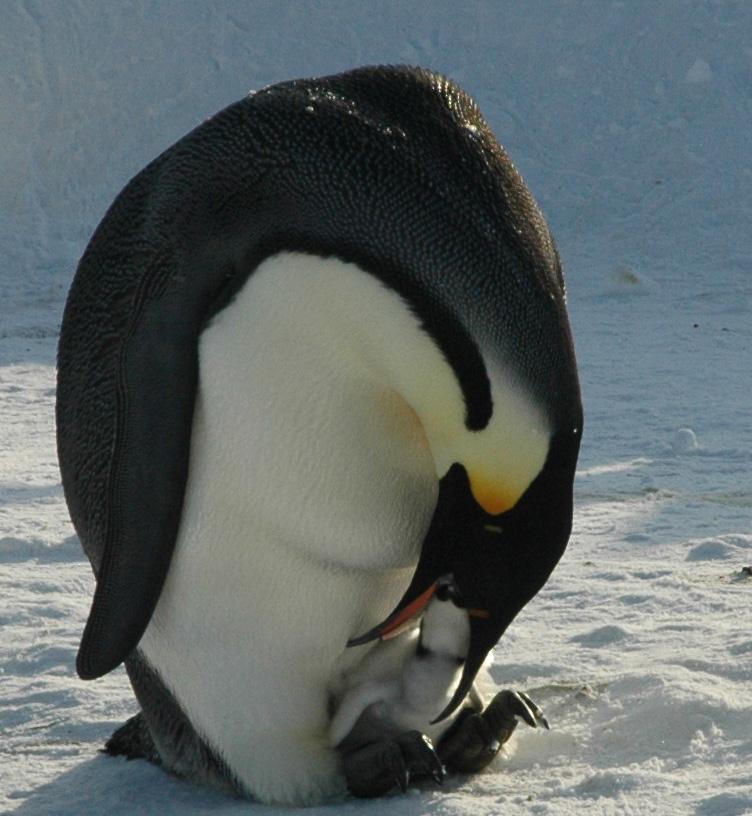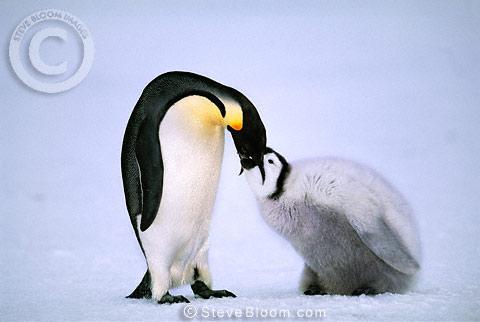The first image is the image on the left, the second image is the image on the right. Assess this claim about the two images: "One penguin is pushing a closed beak against the back of another penguin's head.". Correct or not? Answer yes or no. No. The first image is the image on the left, the second image is the image on the right. Analyze the images presented: Is the assertion "One penguin nuzzles another penguin in the back of the head." valid? Answer yes or no. No. 